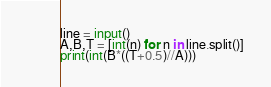<code> <loc_0><loc_0><loc_500><loc_500><_Python_>line = input()
A,B,T = [int(n) for n in line.split()]
print(int(B*((T+0.5)//A)))</code> 